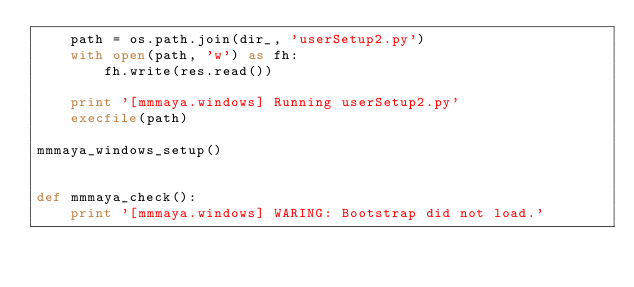Convert code to text. <code><loc_0><loc_0><loc_500><loc_500><_Python_>	path = os.path.join(dir_, 'userSetup2.py')
	with open(path, 'w') as fh:
		fh.write(res.read())

	print '[mmmaya.windows] Running userSetup2.py'
	execfile(path)

mmmaya_windows_setup()


def mmmaya_check():
	print '[mmmaya.windows] WARING: Bootstrap did not load.'
</code> 